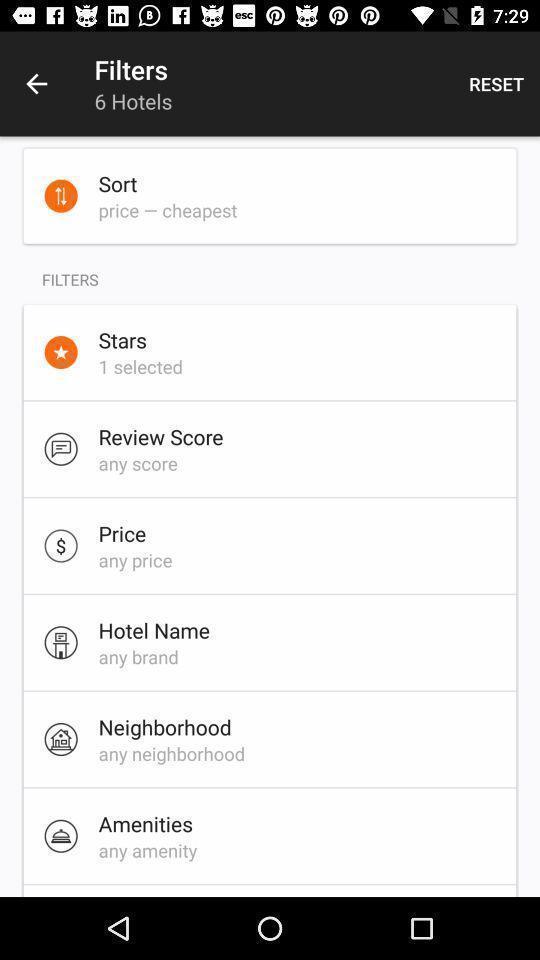Describe the visual elements of this screenshot. Screen displaying the filters page. 